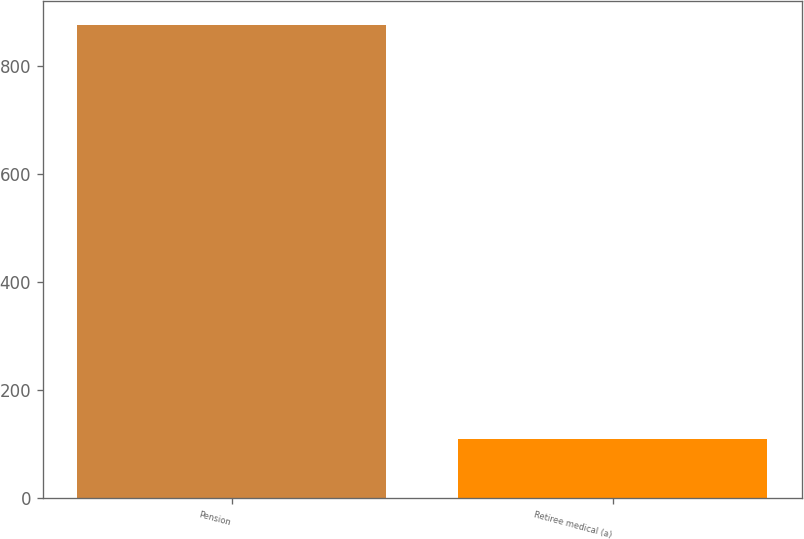Convert chart. <chart><loc_0><loc_0><loc_500><loc_500><bar_chart><fcel>Pension<fcel>Retiree medical (a)<nl><fcel>875<fcel>110<nl></chart> 